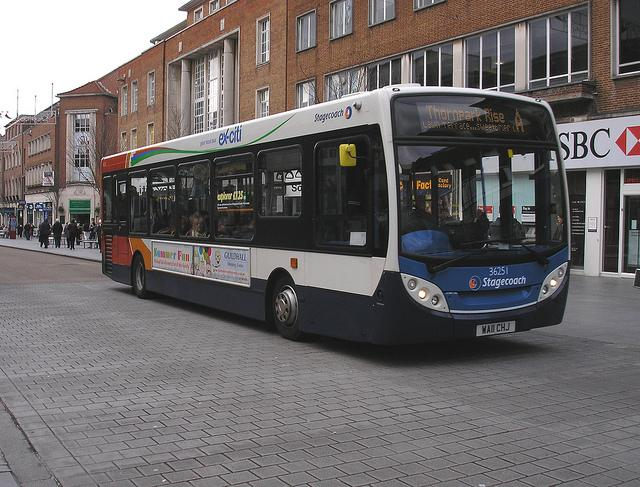What type street does this bus drive on? Please explain your reasoning. brick. This road is a brick road. 